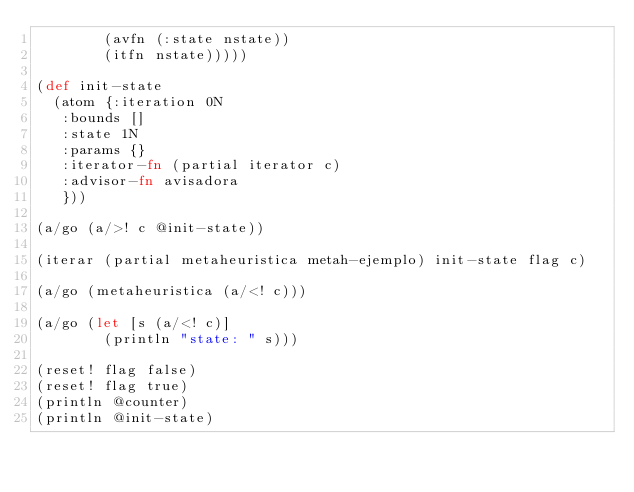<code> <loc_0><loc_0><loc_500><loc_500><_Clojure_>        (avfn (:state nstate))
        (itfn nstate)))))

(def init-state
  (atom {:iteration 0N
   :bounds []
   :state 1N
   :params {}
   :iterator-fn (partial iterator c)
   :advisor-fn avisadora
   }))

(a/go (a/>! c @init-state))

(iterar (partial metaheuristica metah-ejemplo) init-state flag c)

(a/go (metaheuristica (a/<! c)))

(a/go (let [s (a/<! c)]
        (println "state: " s)))

(reset! flag false)
(reset! flag true)
(println @counter)
(println @init-state)


</code> 